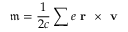<formula> <loc_0><loc_0><loc_500><loc_500>\mathfrak { m } = \frac { 1 } { 2 c } \sum e r \times v</formula> 